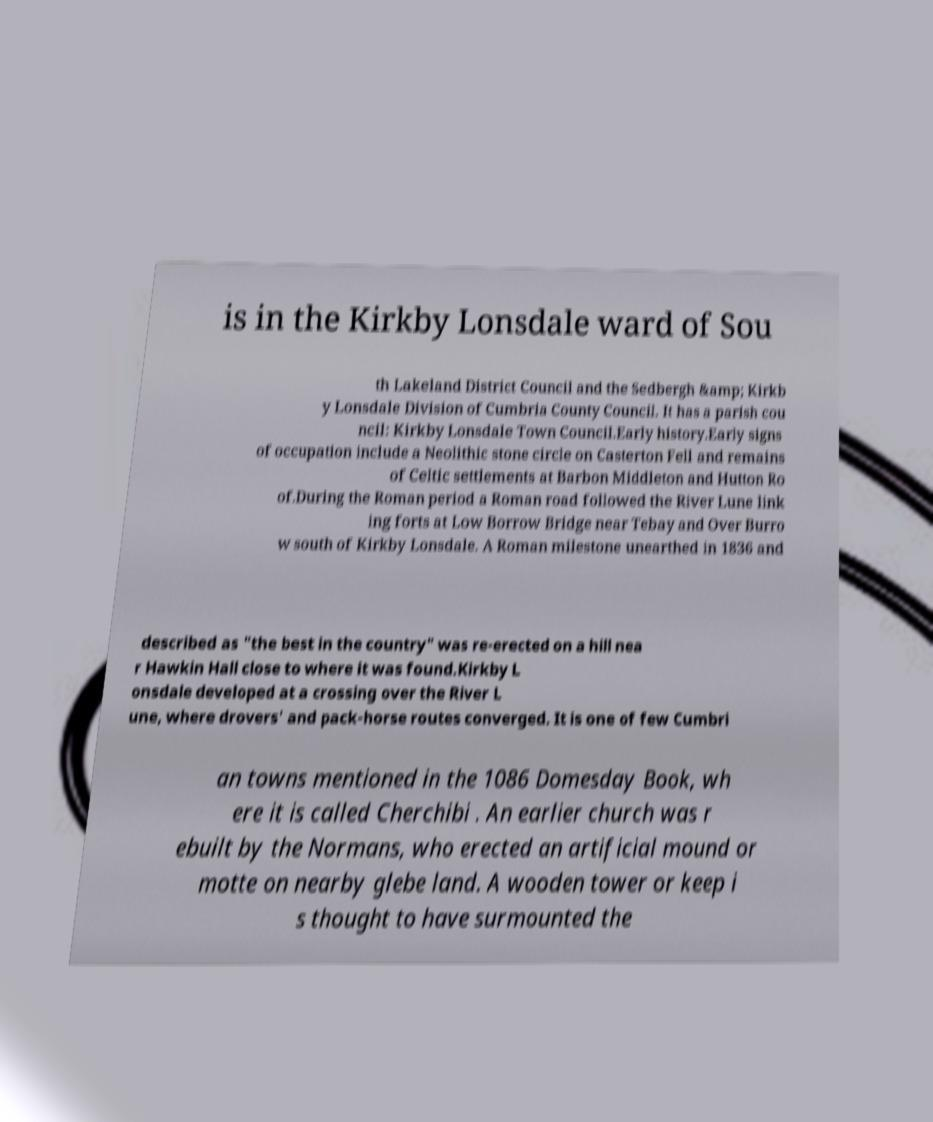There's text embedded in this image that I need extracted. Can you transcribe it verbatim? is in the Kirkby Lonsdale ward of Sou th Lakeland District Council and the Sedbergh &amp; Kirkb y Lonsdale Division of Cumbria County Council. It has a parish cou ncil: Kirkby Lonsdale Town Council.Early history.Early signs of occupation include a Neolithic stone circle on Casterton Fell and remains of Celtic settlements at Barbon Middleton and Hutton Ro of.During the Roman period a Roman road followed the River Lune link ing forts at Low Borrow Bridge near Tebay and Over Burro w south of Kirkby Lonsdale. A Roman milestone unearthed in 1836 and described as "the best in the country" was re-erected on a hill nea r Hawkin Hall close to where it was found.Kirkby L onsdale developed at a crossing over the River L une, where drovers' and pack-horse routes converged. It is one of few Cumbri an towns mentioned in the 1086 Domesday Book, wh ere it is called Cherchibi . An earlier church was r ebuilt by the Normans, who erected an artificial mound or motte on nearby glebe land. A wooden tower or keep i s thought to have surmounted the 